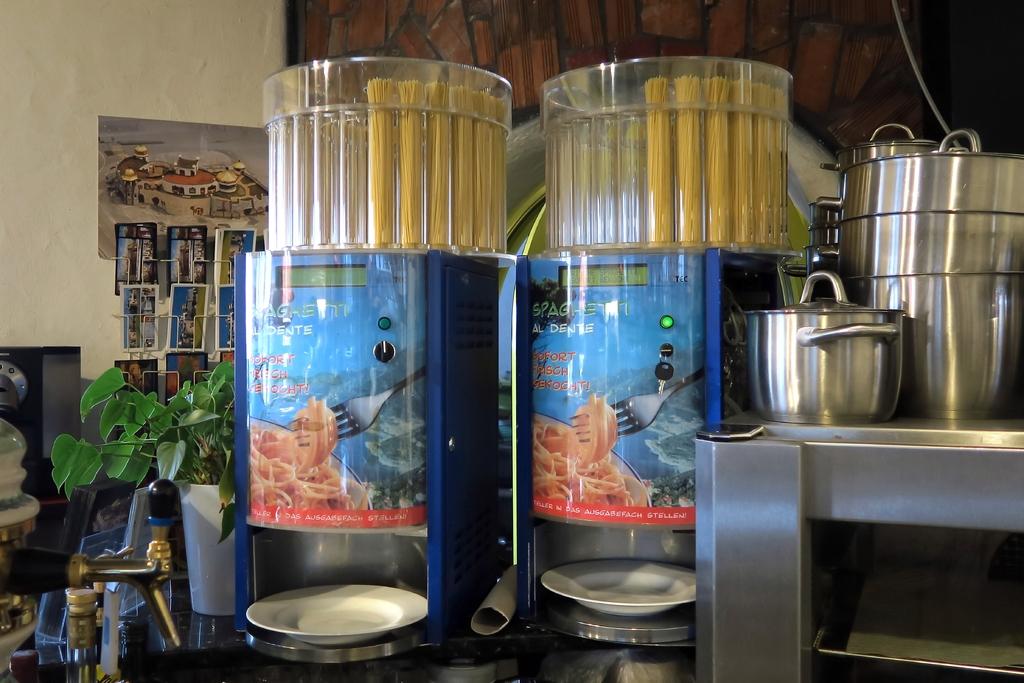What does this machine vend?
Give a very brief answer. Spaghetti. 